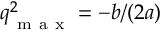<formula> <loc_0><loc_0><loc_500><loc_500>\boldsymbol q _ { m a x } ^ { 2 } = - b / ( 2 a )</formula> 